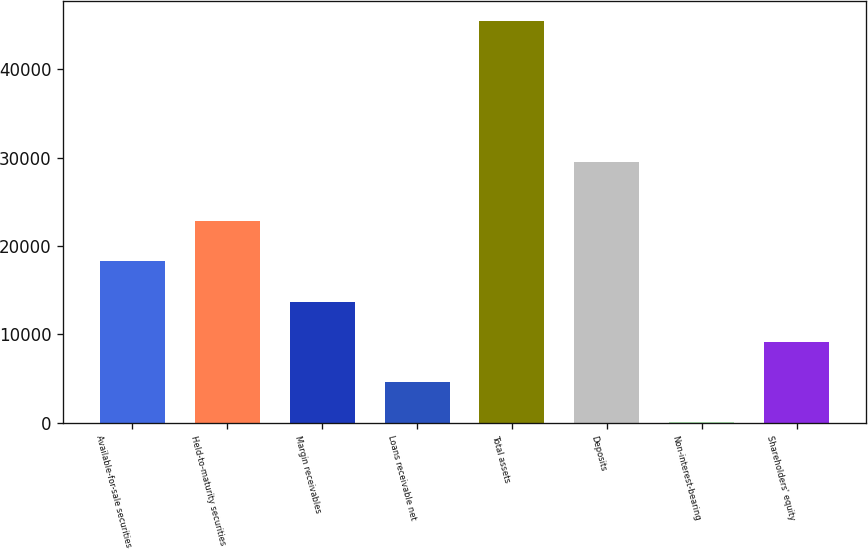Convert chart. <chart><loc_0><loc_0><loc_500><loc_500><bar_chart><fcel>Available-for-sale securities<fcel>Held-to-maturity securities<fcel>Margin receivables<fcel>Loans receivable net<fcel>Total assets<fcel>Deposits<fcel>Non-interest-bearing<fcel>Shareholders' equity<nl><fcel>18238.7<fcel>22780.6<fcel>13696.8<fcel>4613<fcel>45427<fcel>29445<fcel>8<fcel>9154.9<nl></chart> 